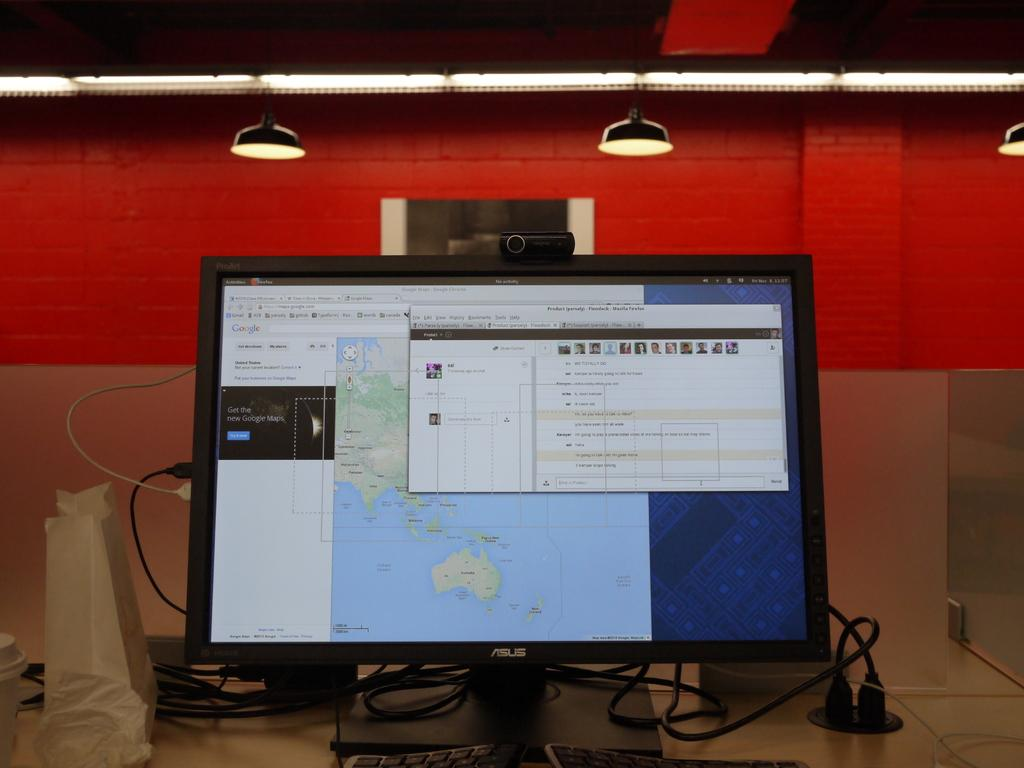<image>
Share a concise interpretation of the image provided. An Asus computer monitor with Google Maps and a flow chart on the screen. 